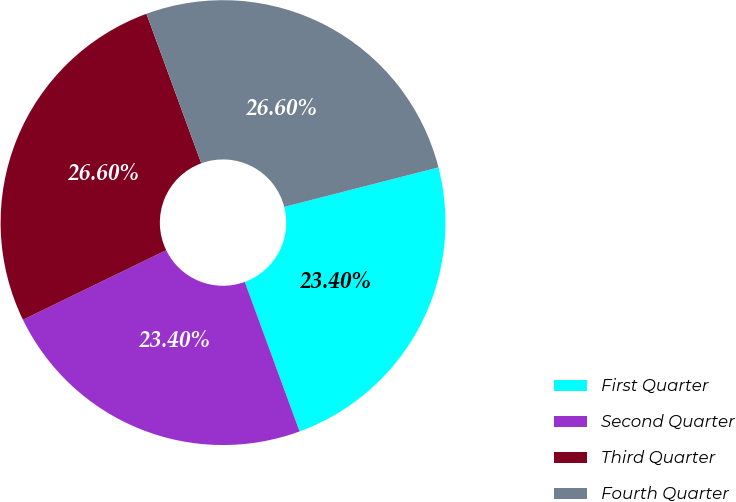Convert chart. <chart><loc_0><loc_0><loc_500><loc_500><pie_chart><fcel>First Quarter<fcel>Second Quarter<fcel>Third Quarter<fcel>Fourth Quarter<nl><fcel>23.4%<fcel>23.4%<fcel>26.6%<fcel>26.6%<nl></chart> 